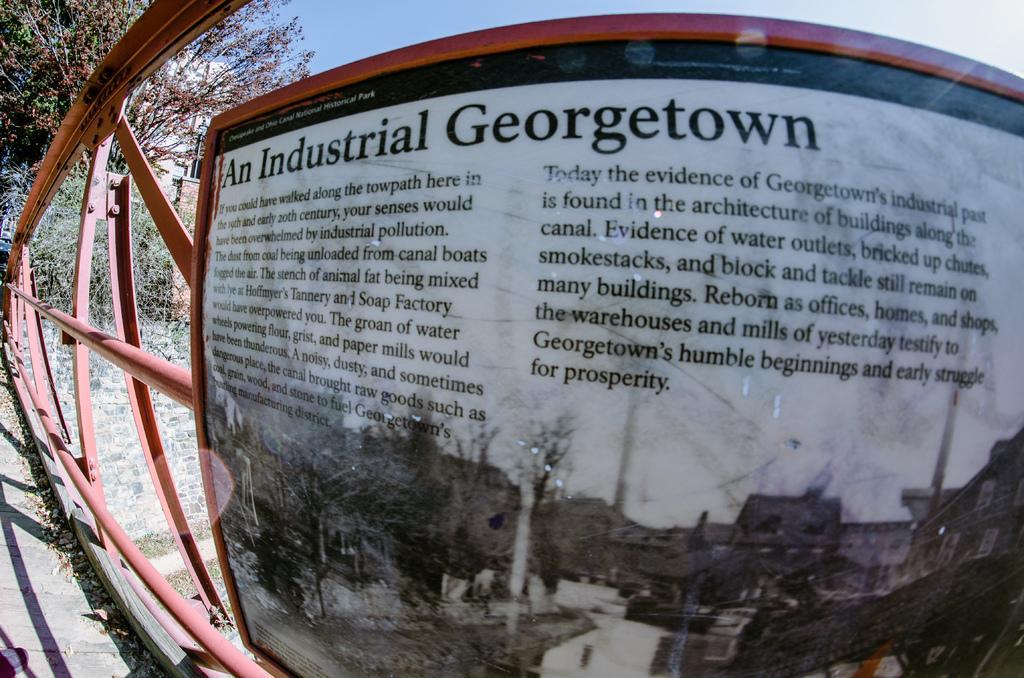Could you give a brief overview of what you see in this image? In this image in the foreground there is a railing and there is one board, on the board there is some text. In the background there are some trees, at the top of the image there is sky. 